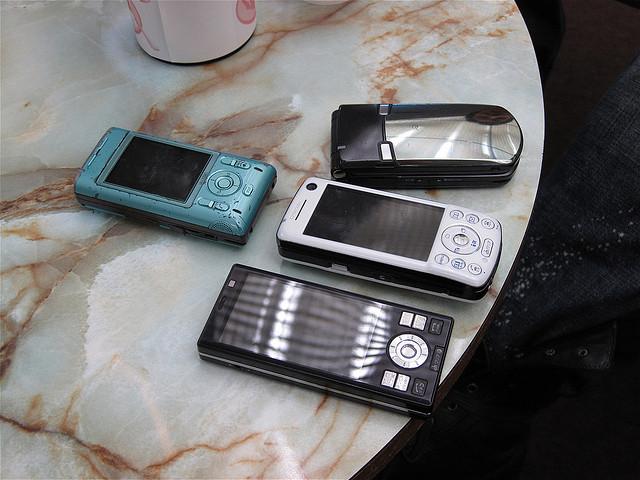What is the table made of?
Be succinct. Marble. How old do you think these phones are?
Give a very brief answer. 7 years. What is present?
Be succinct. Phones. 